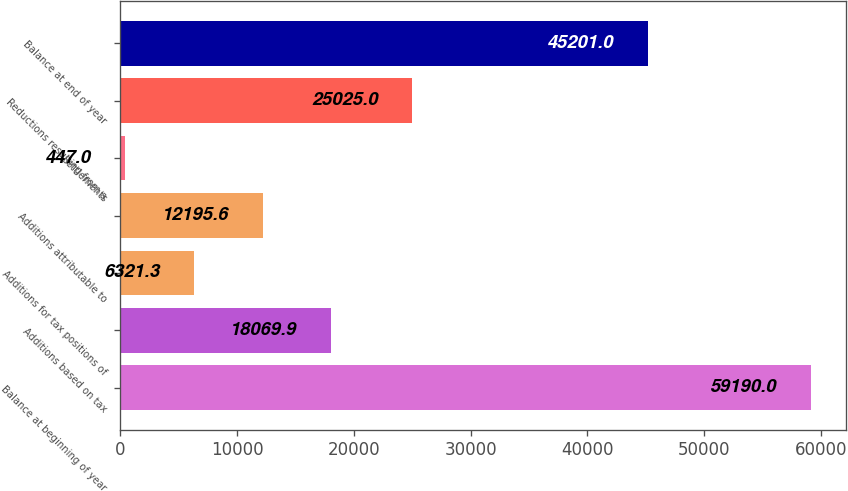<chart> <loc_0><loc_0><loc_500><loc_500><bar_chart><fcel>Balance at beginning of year<fcel>Additions based on tax<fcel>Additions for tax positions of<fcel>Additions attributable to<fcel>Settlements<fcel>Reductions resulting from a<fcel>Balance at end of year<nl><fcel>59190<fcel>18069.9<fcel>6321.3<fcel>12195.6<fcel>447<fcel>25025<fcel>45201<nl></chart> 